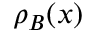<formula> <loc_0><loc_0><loc_500><loc_500>\rho _ { B } ( { x } )</formula> 